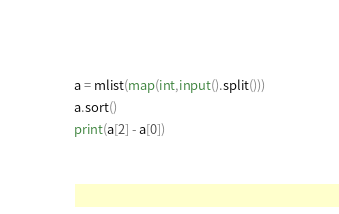<code> <loc_0><loc_0><loc_500><loc_500><_Python_>a = mlist(map(int,input().split()))
a.sort()
print(a[2] - a[0])</code> 